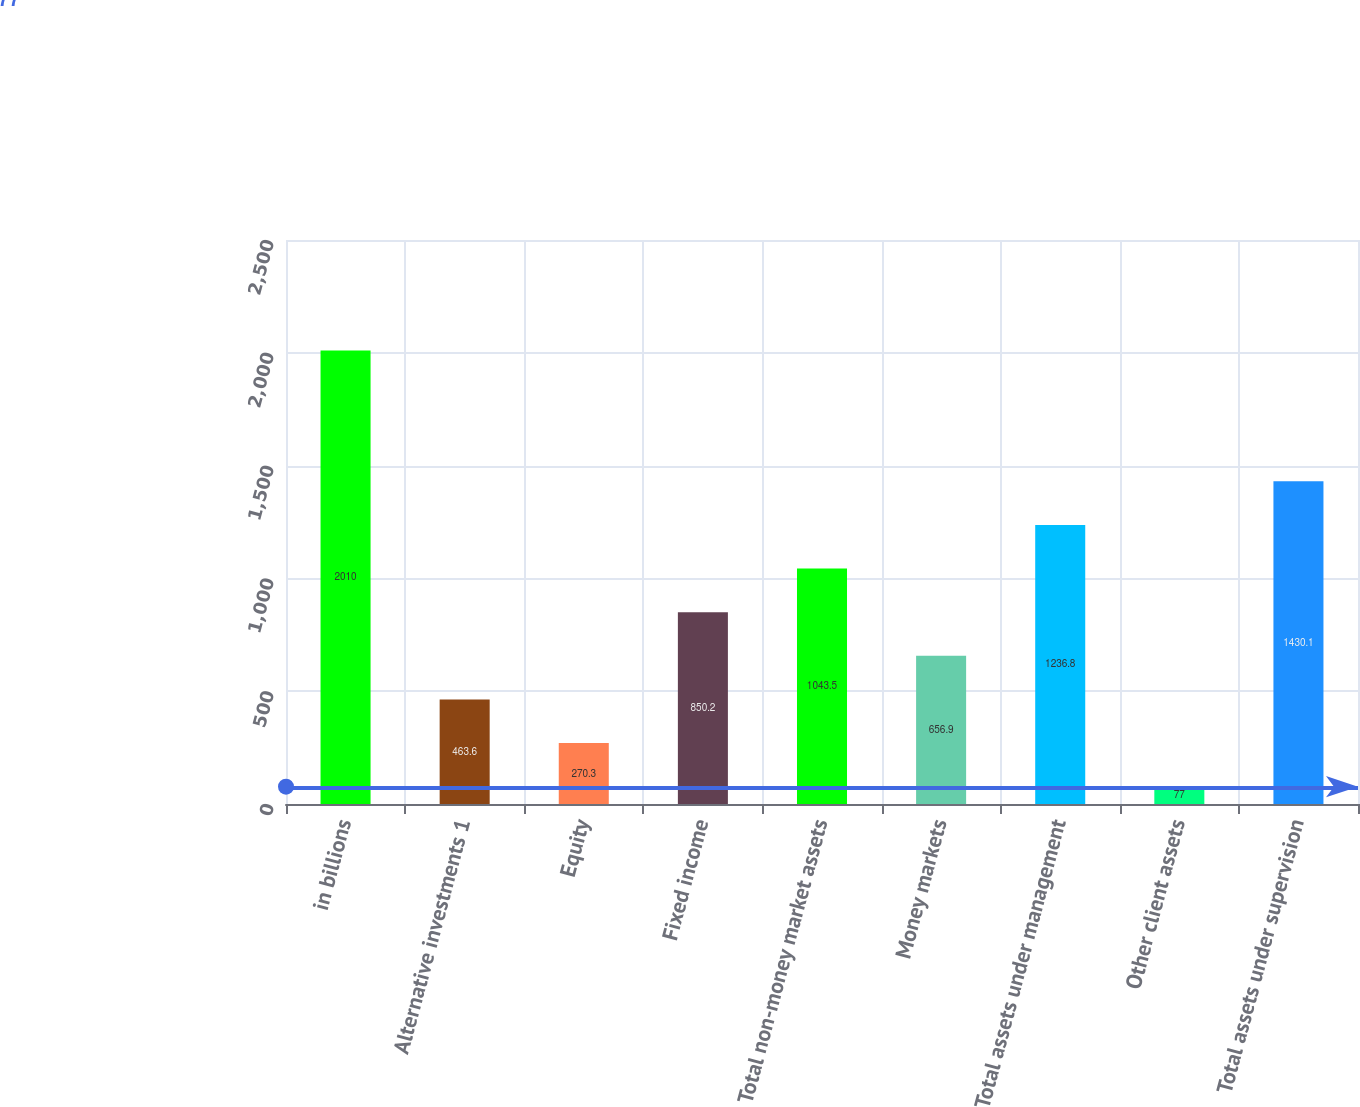Convert chart. <chart><loc_0><loc_0><loc_500><loc_500><bar_chart><fcel>in billions<fcel>Alternative investments 1<fcel>Equity<fcel>Fixed income<fcel>Total non-money market assets<fcel>Money markets<fcel>Total assets under management<fcel>Other client assets<fcel>Total assets under supervision<nl><fcel>2010<fcel>463.6<fcel>270.3<fcel>850.2<fcel>1043.5<fcel>656.9<fcel>1236.8<fcel>77<fcel>1430.1<nl></chart> 